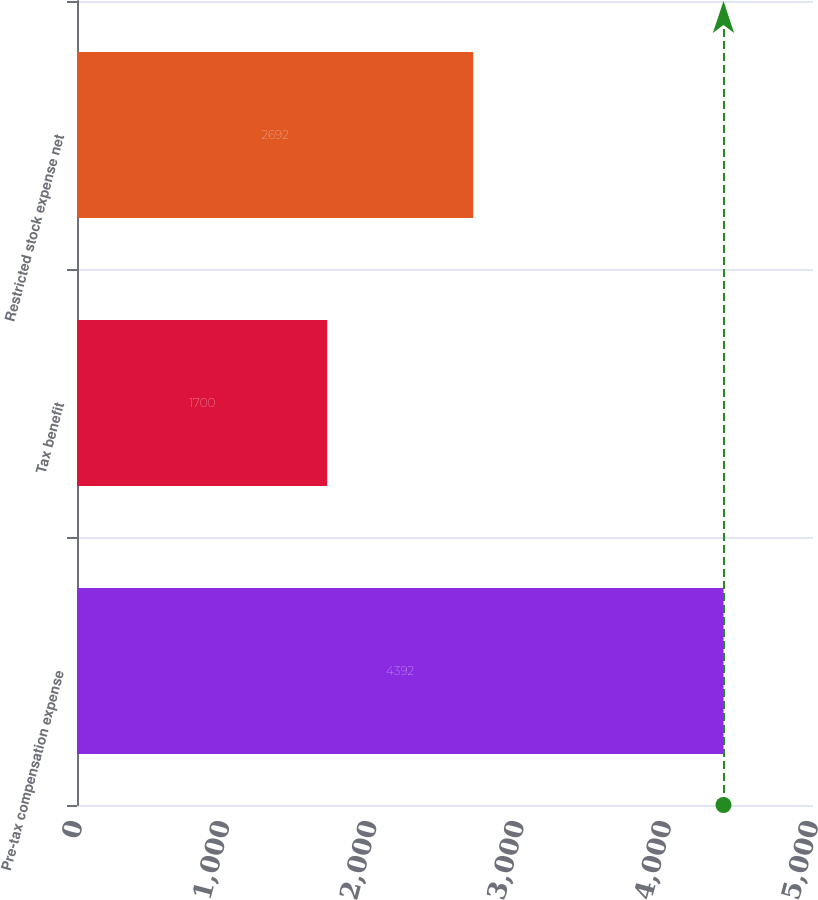<chart> <loc_0><loc_0><loc_500><loc_500><bar_chart><fcel>Pre-tax compensation expense<fcel>Tax benefit<fcel>Restricted stock expense net<nl><fcel>4392<fcel>1700<fcel>2692<nl></chart> 